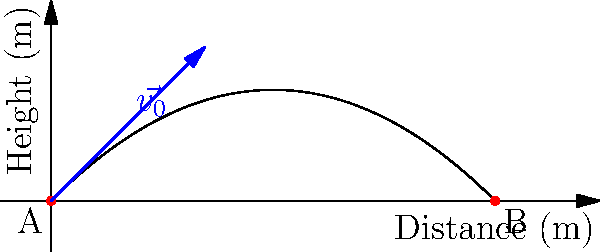In a dramatic scene from the popular Pakistani drama "Ehd-e-Wafa," actor Osman Khalid Butt, playing the role of a cricket enthusiast, throws a ball from point A to point B. If the initial velocity of the ball is 20 m/s at an angle of 45° to the horizontal, what is the maximum height reached by the ball during its flight? To find the maximum height reached by the ball, we can follow these steps:

1. Identify the relevant equations:
   - For vertical motion: $y = v_0 \sin(\theta) t - \frac{1}{2}gt^2$
   - Maximum height occurs when vertical velocity is zero: $v_y = v_0 \sin(\theta) - gt = 0$

2. Find the time to reach maximum height:
   $t_{max} = \frac{v_0 \sin(\theta)}{g}$
   
   $t_{max} = \frac{20 \sin(45°)}{9.8} = \frac{20 \cdot \frac{\sqrt{2}}{2}}{9.8} \approx 1.44$ seconds

3. Substitute this time into the vertical motion equation:
   $y_{max} = v_0 \sin(\theta) t_{max} - \frac{1}{2}g{t_{max}}^2$
   
   $y_{max} = 20 \sin(45°) \cdot 1.44 - \frac{1}{2} \cdot 9.8 \cdot {1.44}^2$

4. Simplify and calculate:
   $y_{max} = 20 \cdot \frac{\sqrt{2}}{2} \cdot 1.44 - 4.9 \cdot 2.07$
   
   $y_{max} = 20.4 - 10.14 = 10.26$ meters

Therefore, the maximum height reached by the ball is approximately 10.26 meters.
Answer: 10.26 meters 